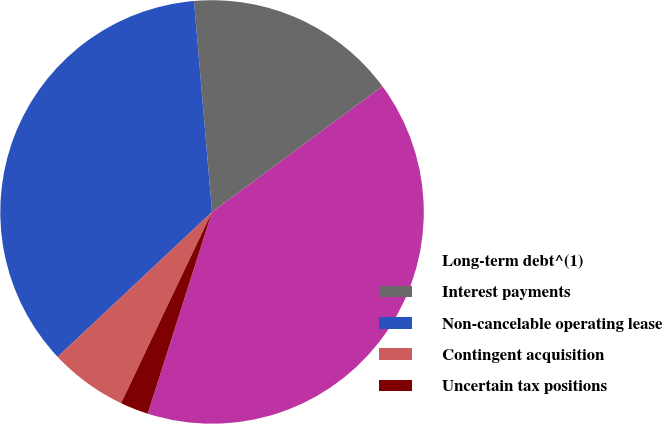Convert chart. <chart><loc_0><loc_0><loc_500><loc_500><pie_chart><fcel>Long-term debt^(1)<fcel>Interest payments<fcel>Non-cancelable operating lease<fcel>Contingent acquisition<fcel>Uncertain tax positions<nl><fcel>40.03%<fcel>16.24%<fcel>35.64%<fcel>5.94%<fcel>2.15%<nl></chart> 